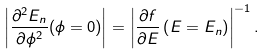<formula> <loc_0><loc_0><loc_500><loc_500>\left | \frac { \partial ^ { 2 } E _ { n } } { \partial \phi ^ { 2 } } ( \phi = 0 ) \right | = \left | \frac { \partial f } { \partial E } \left ( E = E _ { n } \right ) \right | ^ { - 1 } .</formula> 